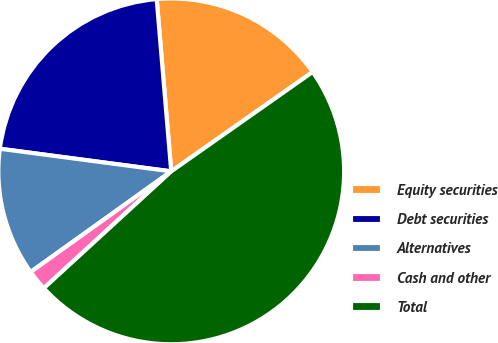Convert chart. <chart><loc_0><loc_0><loc_500><loc_500><pie_chart><fcel>Equity securities<fcel>Debt securities<fcel>Alternatives<fcel>Cash and other<fcel>Total<nl><fcel>16.59%<fcel>21.57%<fcel>11.98%<fcel>1.92%<fcel>47.94%<nl></chart> 